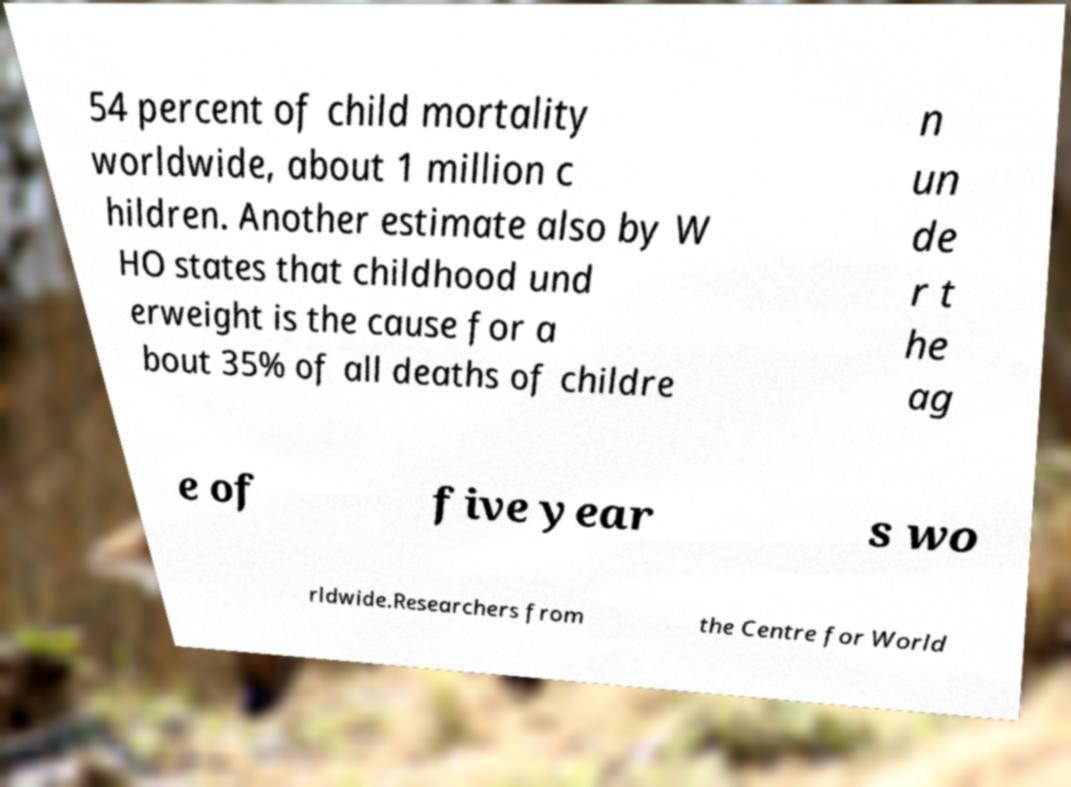Can you read and provide the text displayed in the image?This photo seems to have some interesting text. Can you extract and type it out for me? 54 percent of child mortality worldwide, about 1 million c hildren. Another estimate also by W HO states that childhood und erweight is the cause for a bout 35% of all deaths of childre n un de r t he ag e of five year s wo rldwide.Researchers from the Centre for World 